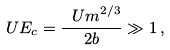Convert formula to latex. <formula><loc_0><loc_0><loc_500><loc_500>\ U E _ { c } = \frac { { \ U m } ^ { 2 / 3 } } { 2 b } \gg 1 \, ,</formula> 